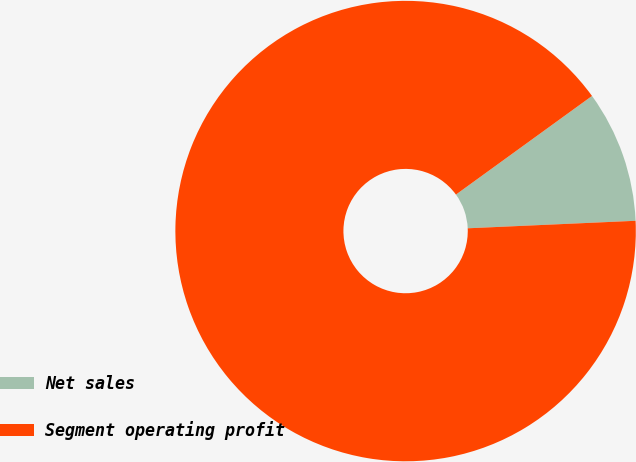Convert chart to OTSL. <chart><loc_0><loc_0><loc_500><loc_500><pie_chart><fcel>Net sales<fcel>Segment operating profit<nl><fcel>9.27%<fcel>90.73%<nl></chart> 